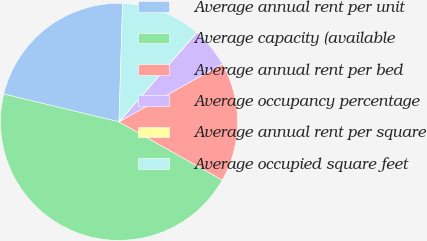<chart> <loc_0><loc_0><loc_500><loc_500><pie_chart><fcel>Average annual rent per unit<fcel>Average capacity (available<fcel>Average annual rent per bed<fcel>Average occupancy percentage<fcel>Average annual rent per square<fcel>Average occupied square feet<nl><fcel>21.71%<fcel>45.6%<fcel>16.29%<fcel>5.47%<fcel>0.05%<fcel>10.88%<nl></chart> 